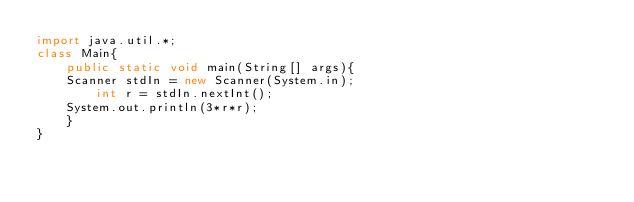<code> <loc_0><loc_0><loc_500><loc_500><_Java_>import java.util.*;
class Main{
    public static void main(String[] args){
	Scanner stdIn = new Scanner(System.in);
        int r = stdIn.nextInt();
	System.out.println(3*r*r);
    }
}
</code> 